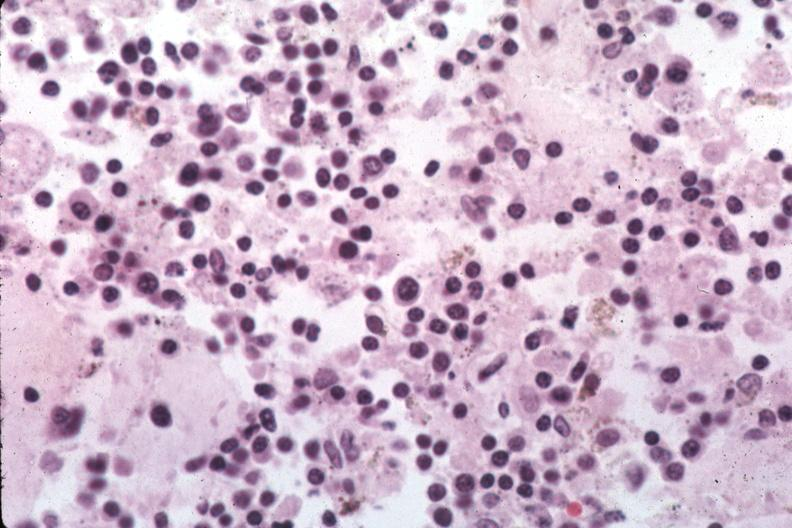re organisms easily evident?
Answer the question using a single word or phrase. Yes 